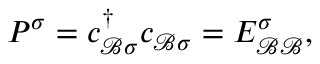Convert formula to latex. <formula><loc_0><loc_0><loc_500><loc_500>\begin{array} { r } { P ^ { \sigma } = { c } _ { \mathcal { B } \sigma } ^ { \dagger } { c } _ { \mathcal { B } \sigma } = E _ { \mathcal { B B } } ^ { \sigma } , } \end{array}</formula> 